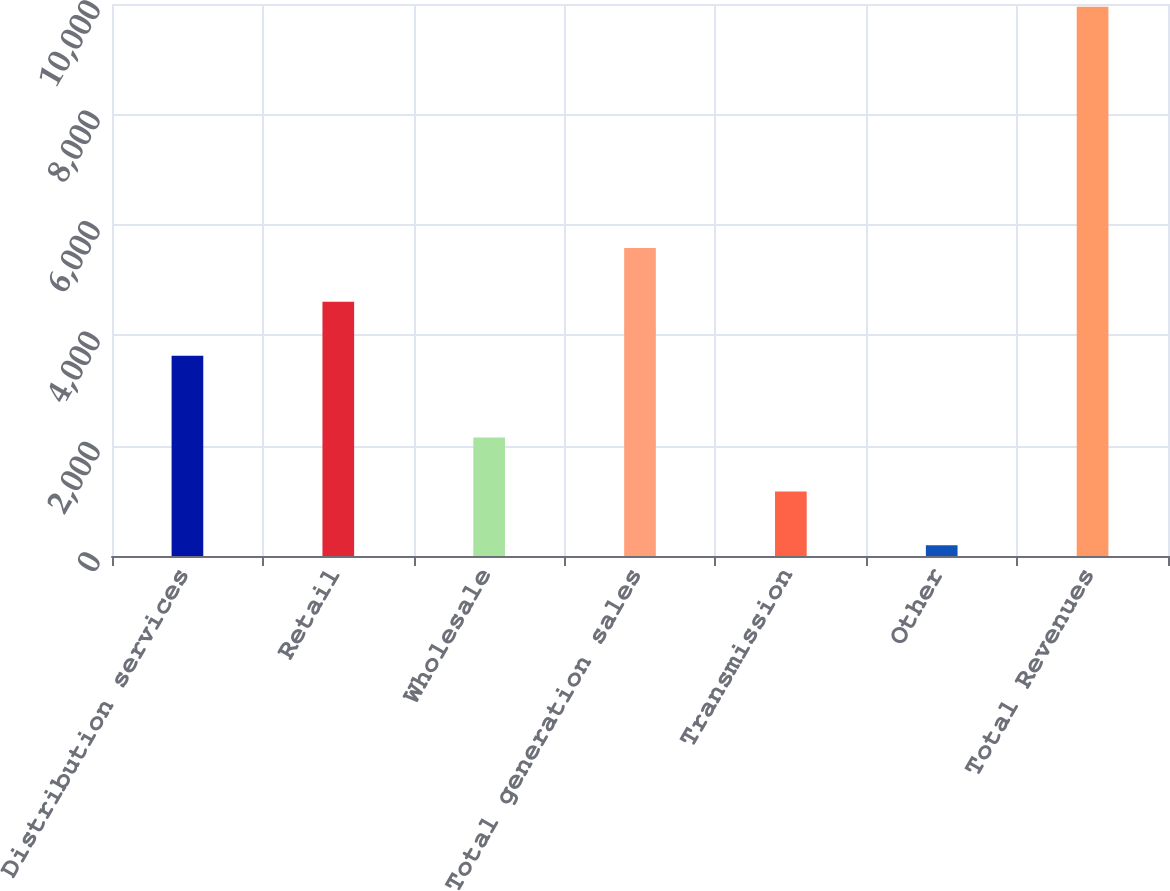Convert chart to OTSL. <chart><loc_0><loc_0><loc_500><loc_500><bar_chart><fcel>Distribution services<fcel>Retail<fcel>Wholesale<fcel>Total generation sales<fcel>Transmission<fcel>Other<fcel>Total Revenues<nl><fcel>3629<fcel>4604.9<fcel>2144.8<fcel>5580.8<fcel>1168.9<fcel>193<fcel>9952<nl></chart> 